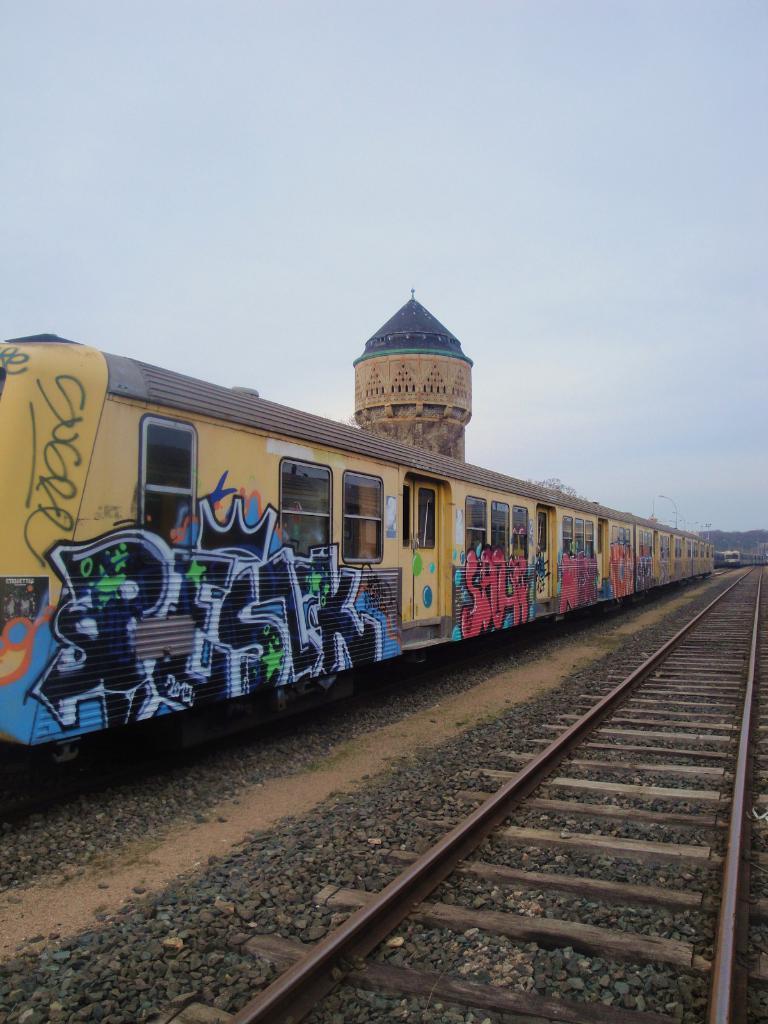In one or two sentences, can you explain what this image depicts? In this picture we can see trains, here we can see a railway track and in the background we can see a building, electric poles and sky. 